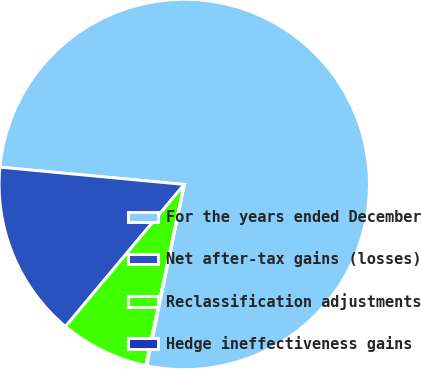Convert chart to OTSL. <chart><loc_0><loc_0><loc_500><loc_500><pie_chart><fcel>For the years ended December<fcel>Net after-tax gains (losses)<fcel>Reclassification adjustments<fcel>Hedge ineffectiveness gains<nl><fcel>76.76%<fcel>15.41%<fcel>7.75%<fcel>0.08%<nl></chart> 